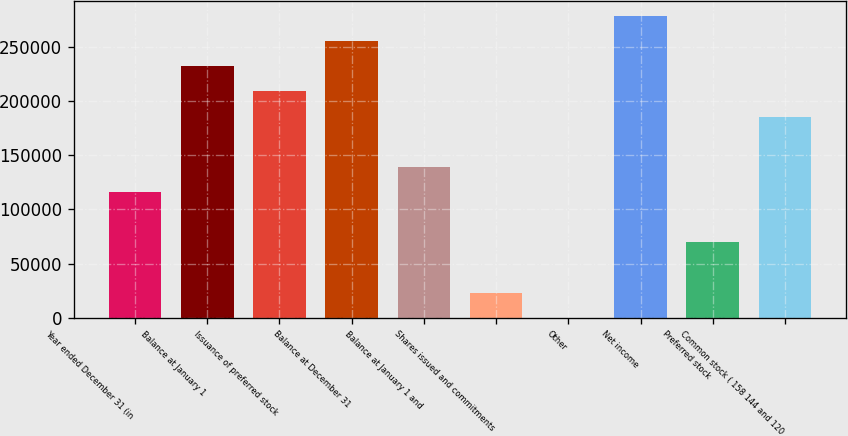Convert chart to OTSL. <chart><loc_0><loc_0><loc_500><loc_500><bar_chart><fcel>Year ended December 31 (in<fcel>Balance at January 1<fcel>Issuance of preferred stock<fcel>Balance at December 31<fcel>Balance at January 1 and<fcel>Shares issued and commitments<fcel>Other<fcel>Net income<fcel>Preferred stock<fcel>Common stock ( 158 144 and 120<nl><fcel>116058<fcel>232065<fcel>208864<fcel>255266<fcel>139259<fcel>23251.5<fcel>50<fcel>278468<fcel>69654.5<fcel>185662<nl></chart> 